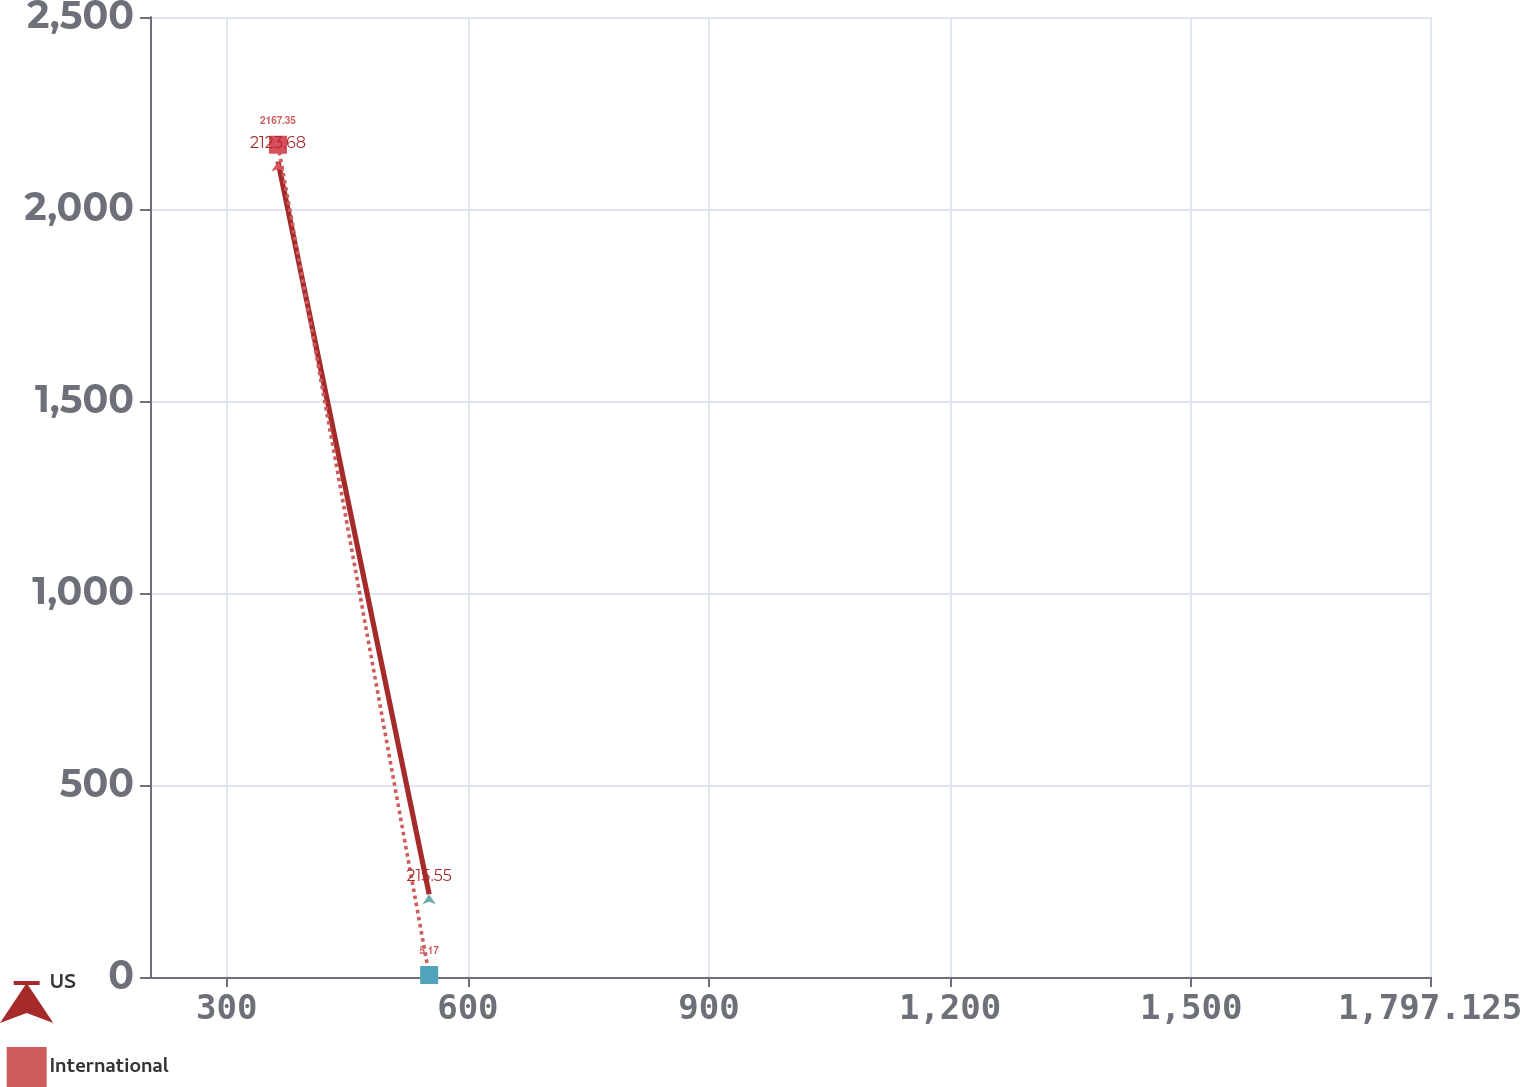Convert chart. <chart><loc_0><loc_0><loc_500><loc_500><line_chart><ecel><fcel>US<fcel>International<nl><fcel>363.74<fcel>2123.68<fcel>2167.35<nl><fcel>551.83<fcel>215.55<fcel>5.17<nl><fcel>1956.39<fcel>3.54<fcel>221.39<nl></chart> 